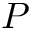Convert formula to latex. <formula><loc_0><loc_0><loc_500><loc_500>P</formula> 